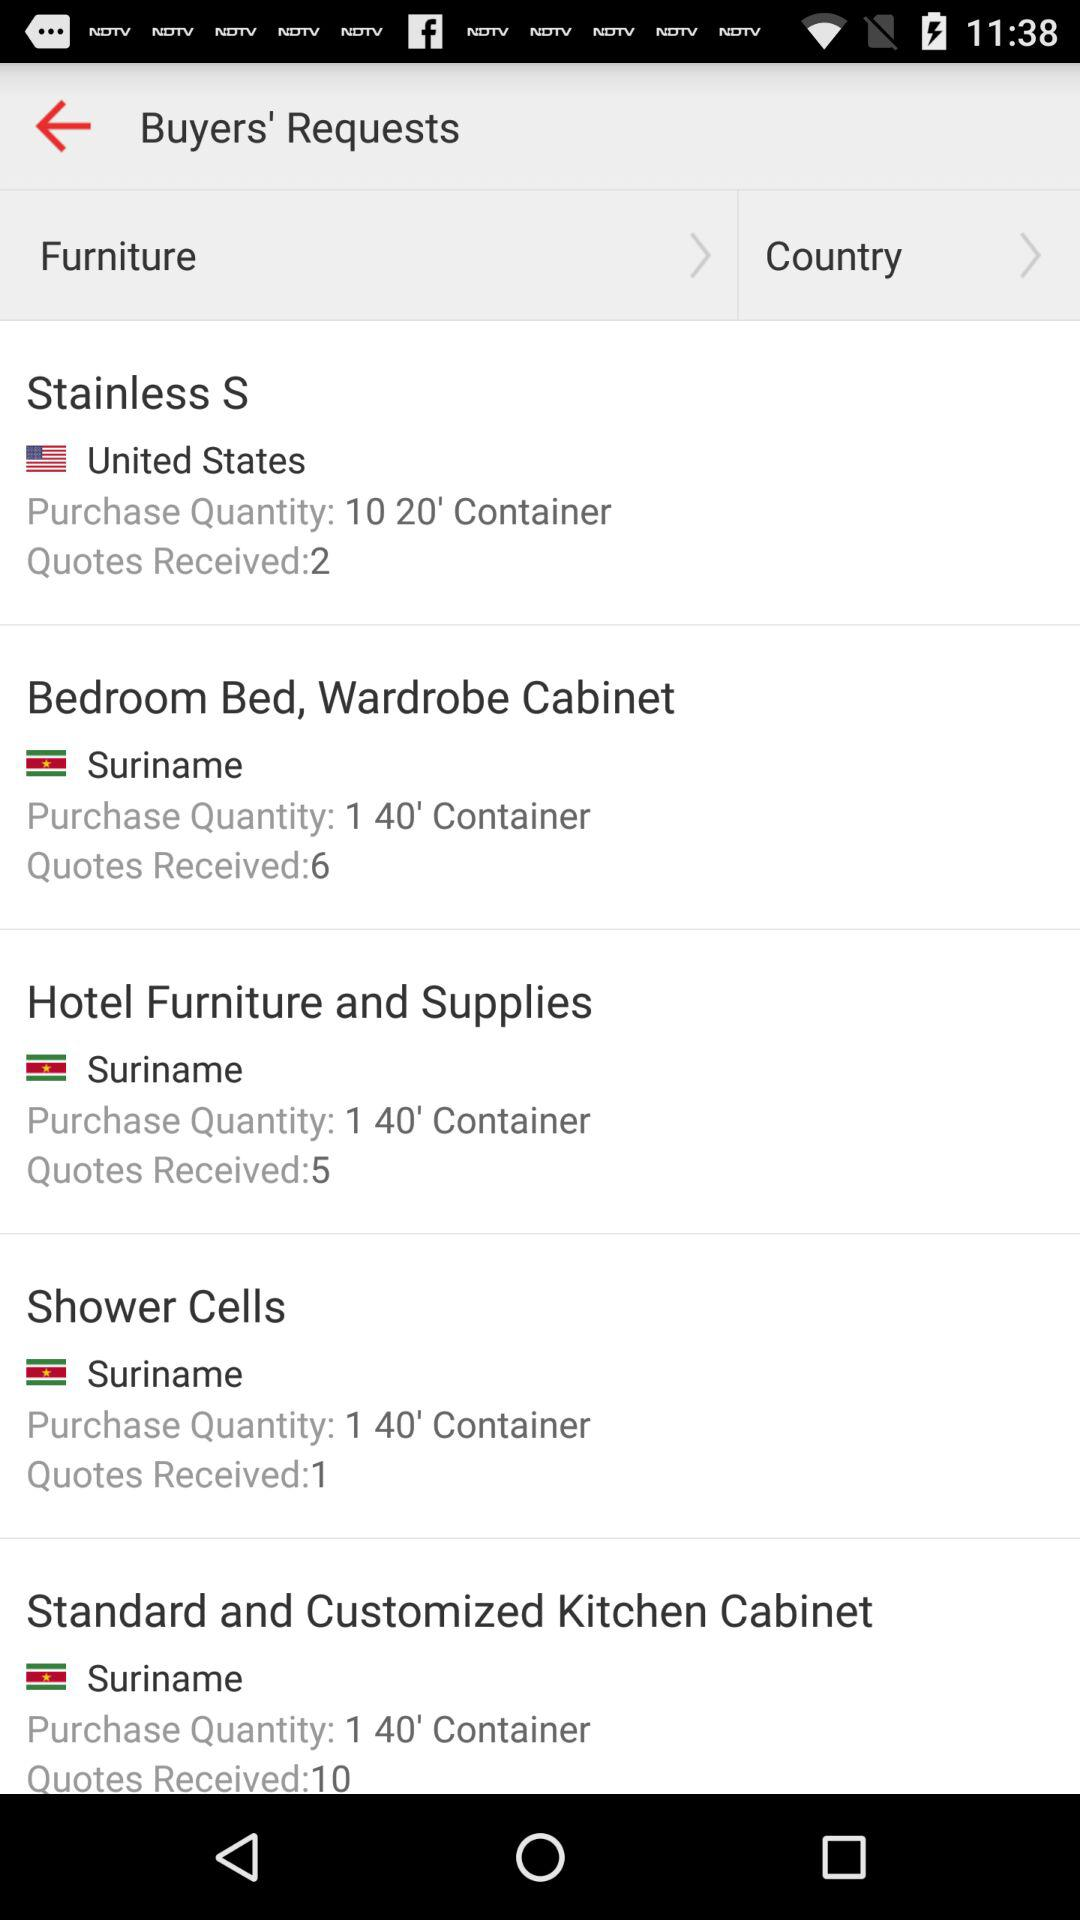What is the purchase quantity of "Hotel Furniture and Supplies"? The purchase quantity of "Hotel Furniture and Supplies" is 1. 